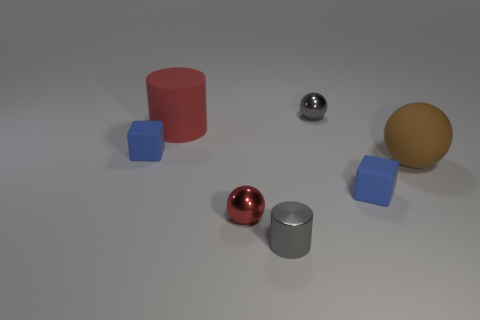Subtract all tiny balls. How many balls are left? 1 Add 3 shiny spheres. How many objects exist? 10 Subtract 2 spheres. How many spheres are left? 1 Subtract all gray spheres. How many spheres are left? 2 Subtract all blocks. How many objects are left? 5 Subtract all cyan cylinders. How many gray spheres are left? 1 Subtract all small gray metal objects. Subtract all tiny gray shiny cylinders. How many objects are left? 4 Add 4 blue matte objects. How many blue matte objects are left? 6 Add 4 small balls. How many small balls exist? 6 Subtract 0 yellow cubes. How many objects are left? 7 